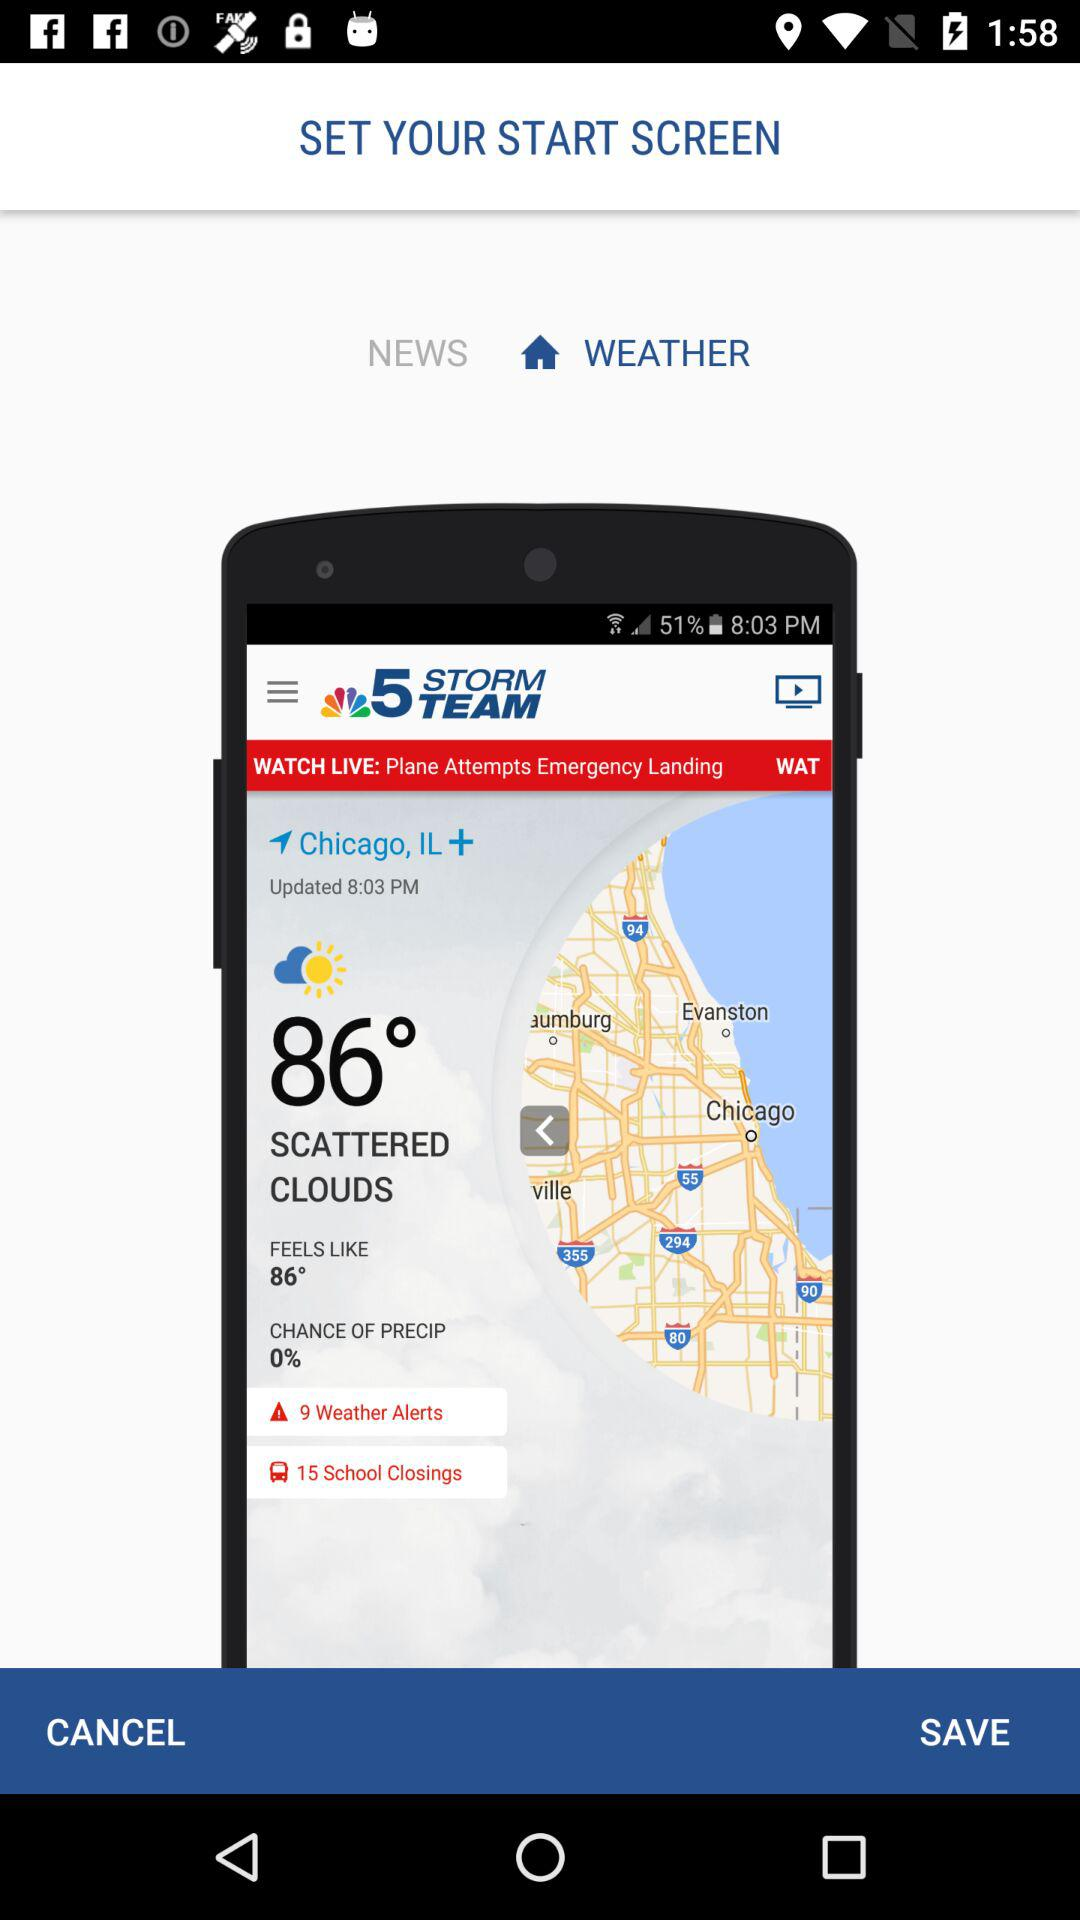What is the location? The location is Chicago, IL. 